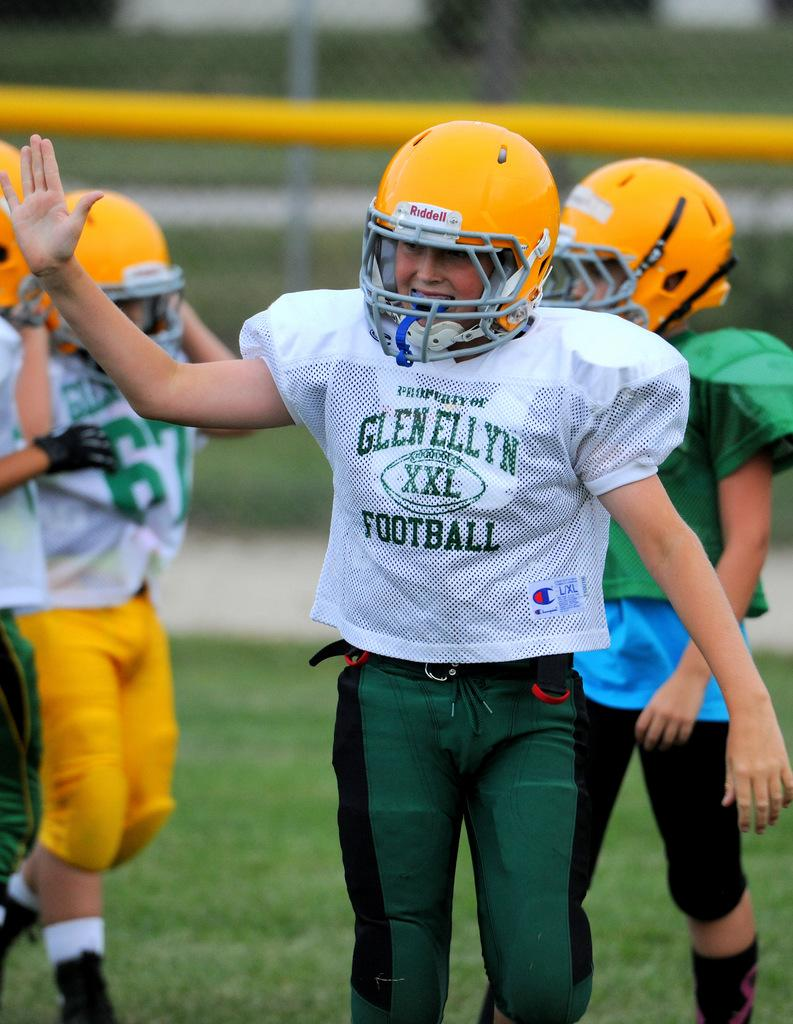What are the people in the image wearing on their heads? The people in the image are wearing helmets. What can be seen beneath the people's feet in the image? The ground is visible in the image. What type of vegetation is present on the ground? Grass is present on the ground. How would you describe the background of the image? The background of the image is blurred. What month is the protest taking place in the image? There is no protest present in the image, and therefore no month can be determined. What type of gardening tool is being used by the person in the image? There is no gardening tool or person using one present in the image. 